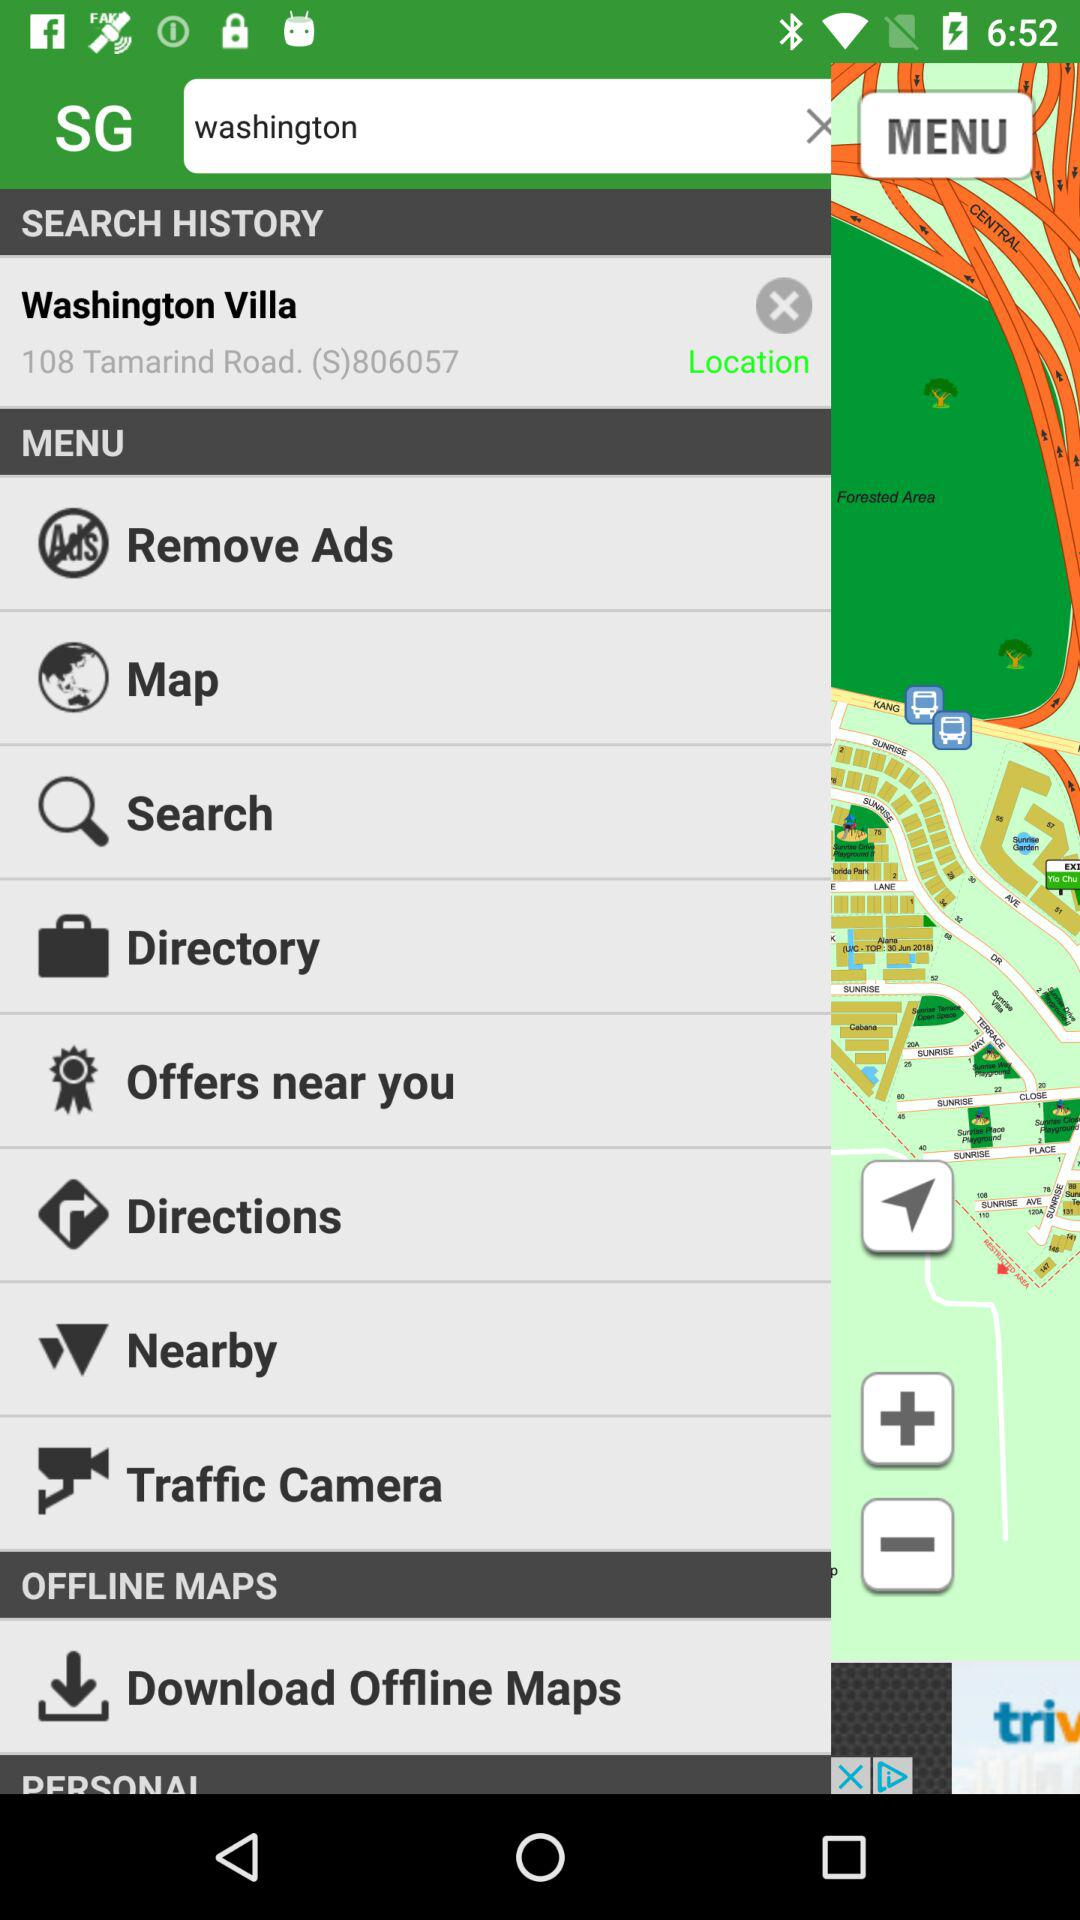What is the selected location? The selected location is 108 Tamarind Road. (S)806057. 